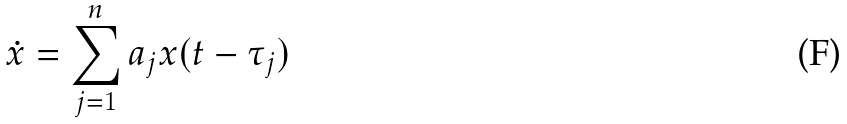Convert formula to latex. <formula><loc_0><loc_0><loc_500><loc_500>\dot { x } = \sum _ { j = 1 } ^ { n } a _ { j } x ( t - \tau _ { j } )</formula> 